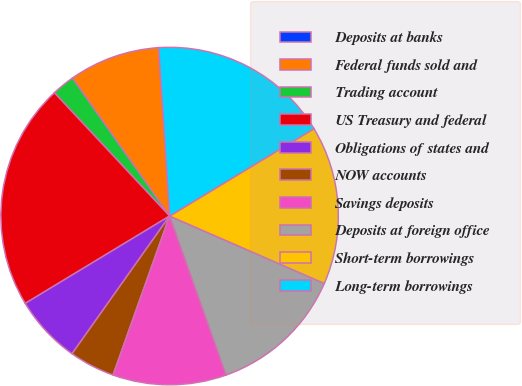<chart> <loc_0><loc_0><loc_500><loc_500><pie_chart><fcel>Deposits at banks<fcel>Federal funds sold and<fcel>Trading account<fcel>US Treasury and federal<fcel>Obligations of states and<fcel>NOW accounts<fcel>Savings deposits<fcel>Deposits at foreign office<fcel>Short-term borrowings<fcel>Long-term borrowings<nl><fcel>0.03%<fcel>8.7%<fcel>2.2%<fcel>21.7%<fcel>6.53%<fcel>4.37%<fcel>10.87%<fcel>13.03%<fcel>15.2%<fcel>17.37%<nl></chart> 